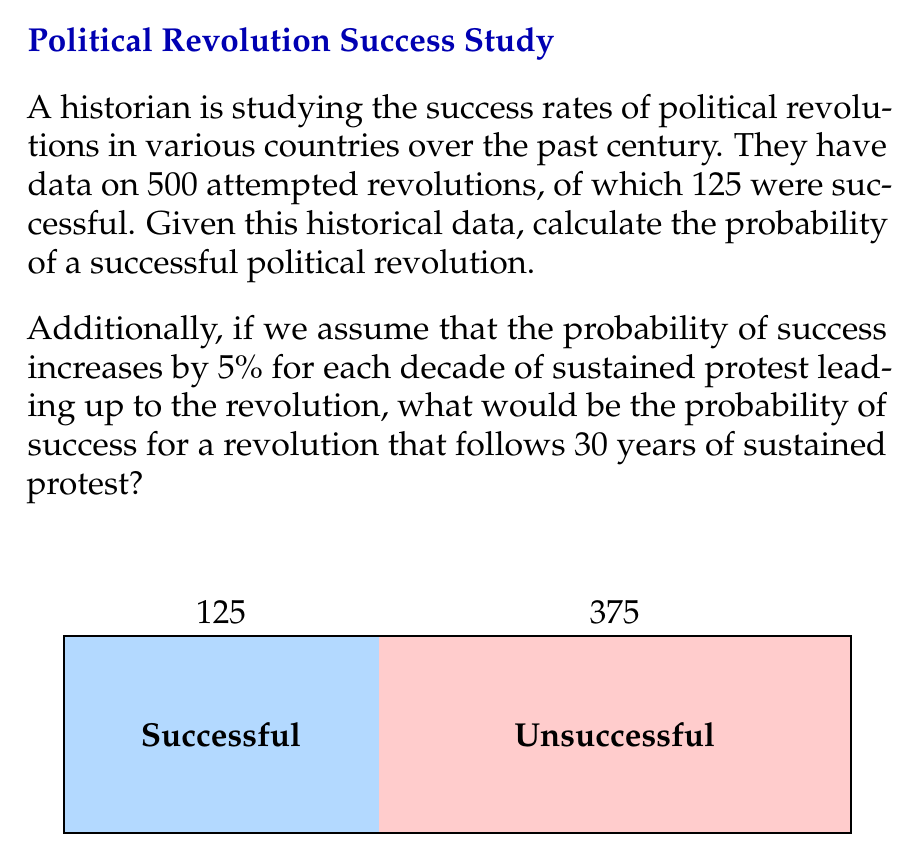Can you solve this math problem? Let's approach this problem step-by-step:

1) First, we need to calculate the basic probability of a successful revolution based on the given data.

   Total number of revolutions: 500
   Number of successful revolutions: 125

   The probability is calculated by dividing the number of successful outcomes by the total number of outcomes:

   $$P(\text{success}) = \frac{\text{Number of successful revolutions}}{\text{Total number of revolutions}} = \frac{125}{500} = 0.25 = 25\%$$

2) For the second part of the question, we need to factor in the increased probability due to sustained protest.

   The probability increases by 5% (or 0.05) for each decade of sustained protest.
   The revolution follows 30 years of sustained protest, which is 3 decades.

   Increase in probability: $3 \times 0.05 = 0.15 = 15\%$

3) To calculate the new probability, we add this increase to our original probability:

   $$P(\text{success with sustained protest}) = 0.25 + 0.15 = 0.40 = 40\%$$

Therefore, the probability of success for a revolution that follows 30 years of sustained protest would be 40%.
Answer: 25% for basic probability; 40% with 30 years of sustained protest 